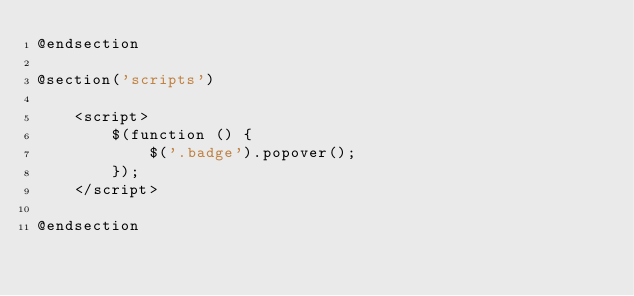<code> <loc_0><loc_0><loc_500><loc_500><_PHP_>@endsection

@section('scripts')

    <script>
        $(function () {
            $('.badge').popover();
        });
    </script>

@endsection</code> 